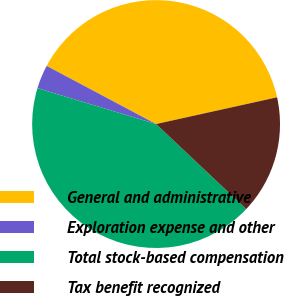Convert chart to OTSL. <chart><loc_0><loc_0><loc_500><loc_500><pie_chart><fcel>General and administrative<fcel>Exploration expense and other<fcel>Total stock-based compensation<fcel>Tax benefit recognized<nl><fcel>38.76%<fcel>3.1%<fcel>42.64%<fcel>15.5%<nl></chart> 